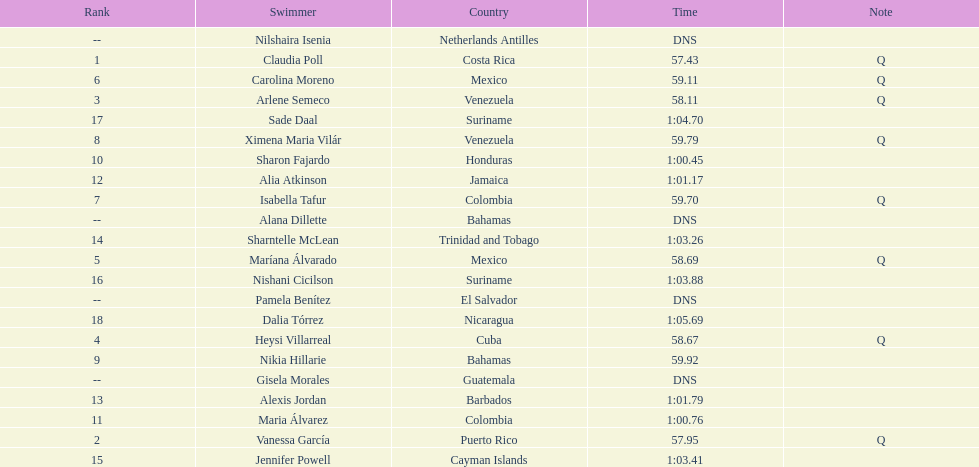How many mexican swimmers ranked in the top 10? 2. 